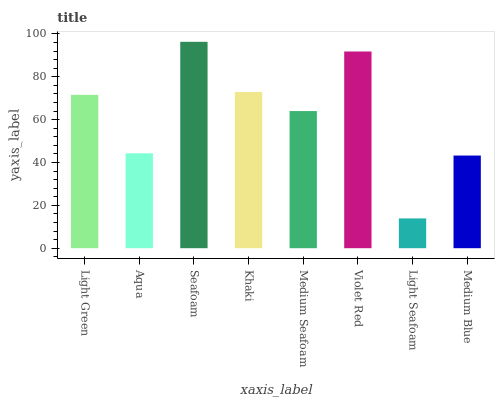Is Aqua the minimum?
Answer yes or no. No. Is Aqua the maximum?
Answer yes or no. No. Is Light Green greater than Aqua?
Answer yes or no. Yes. Is Aqua less than Light Green?
Answer yes or no. Yes. Is Aqua greater than Light Green?
Answer yes or no. No. Is Light Green less than Aqua?
Answer yes or no. No. Is Light Green the high median?
Answer yes or no. Yes. Is Medium Seafoam the low median?
Answer yes or no. Yes. Is Violet Red the high median?
Answer yes or no. No. Is Medium Blue the low median?
Answer yes or no. No. 